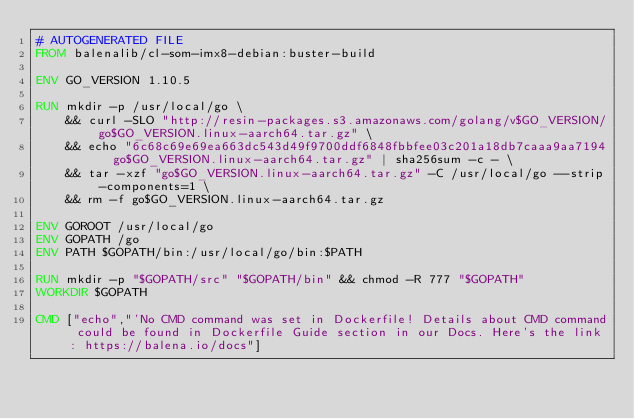Convert code to text. <code><loc_0><loc_0><loc_500><loc_500><_Dockerfile_># AUTOGENERATED FILE
FROM balenalib/cl-som-imx8-debian:buster-build

ENV GO_VERSION 1.10.5

RUN mkdir -p /usr/local/go \
	&& curl -SLO "http://resin-packages.s3.amazonaws.com/golang/v$GO_VERSION/go$GO_VERSION.linux-aarch64.tar.gz" \
	&& echo "6c68c69e69ea663dc543d49f9700ddf6848fbbfee03c201a18db7caaa9aa7194  go$GO_VERSION.linux-aarch64.tar.gz" | sha256sum -c - \
	&& tar -xzf "go$GO_VERSION.linux-aarch64.tar.gz" -C /usr/local/go --strip-components=1 \
	&& rm -f go$GO_VERSION.linux-aarch64.tar.gz

ENV GOROOT /usr/local/go
ENV GOPATH /go
ENV PATH $GOPATH/bin:/usr/local/go/bin:$PATH

RUN mkdir -p "$GOPATH/src" "$GOPATH/bin" && chmod -R 777 "$GOPATH"
WORKDIR $GOPATH

CMD ["echo","'No CMD command was set in Dockerfile! Details about CMD command could be found in Dockerfile Guide section in our Docs. Here's the link: https://balena.io/docs"]</code> 